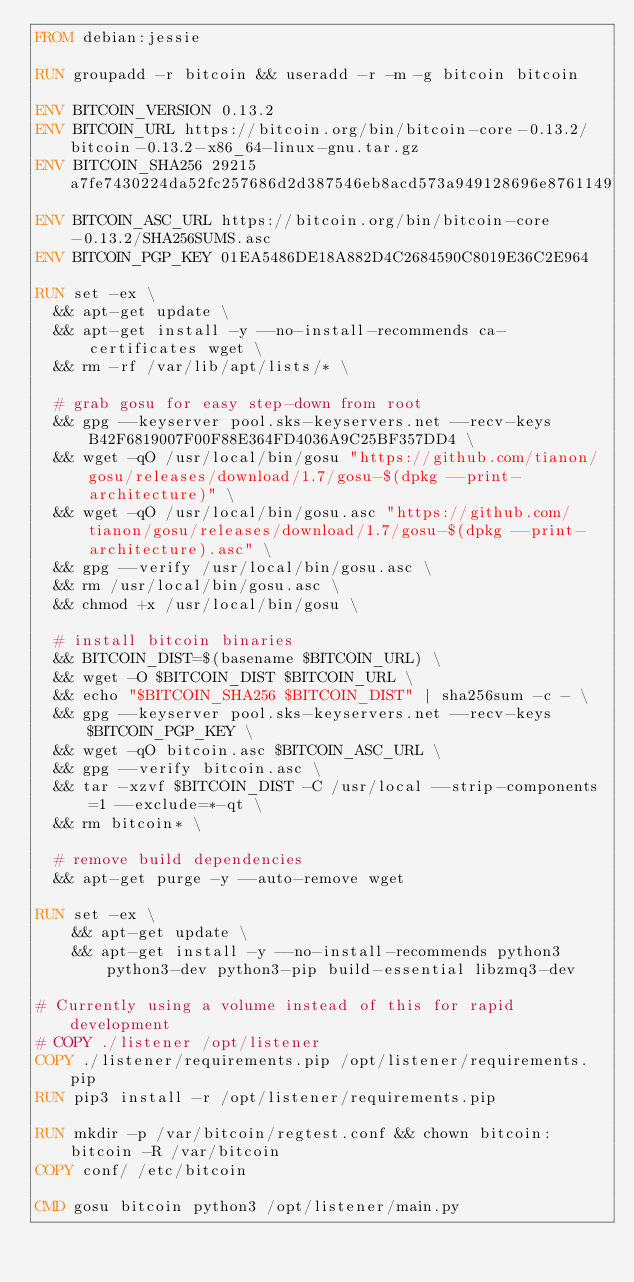<code> <loc_0><loc_0><loc_500><loc_500><_Dockerfile_>FROM debian:jessie

RUN groupadd -r bitcoin && useradd -r -m -g bitcoin bitcoin

ENV BITCOIN_VERSION 0.13.2
ENV BITCOIN_URL https://bitcoin.org/bin/bitcoin-core-0.13.2/bitcoin-0.13.2-x86_64-linux-gnu.tar.gz
ENV BITCOIN_SHA256 29215a7fe7430224da52fc257686d2d387546eb8acd573a949128696e8761149
ENV BITCOIN_ASC_URL https://bitcoin.org/bin/bitcoin-core-0.13.2/SHA256SUMS.asc
ENV BITCOIN_PGP_KEY 01EA5486DE18A882D4C2684590C8019E36C2E964

RUN set -ex \
	&& apt-get update \
	&& apt-get install -y --no-install-recommends ca-certificates wget \
	&& rm -rf /var/lib/apt/lists/* \

	# grab gosu for easy step-down from root
	&& gpg --keyserver pool.sks-keyservers.net --recv-keys B42F6819007F00F88E364FD4036A9C25BF357DD4 \
	&& wget -qO /usr/local/bin/gosu "https://github.com/tianon/gosu/releases/download/1.7/gosu-$(dpkg --print-architecture)" \
	&& wget -qO /usr/local/bin/gosu.asc "https://github.com/tianon/gosu/releases/download/1.7/gosu-$(dpkg --print-architecture).asc" \
	&& gpg --verify /usr/local/bin/gosu.asc \
	&& rm /usr/local/bin/gosu.asc \
	&& chmod +x /usr/local/bin/gosu \

	# install bitcoin binaries
	&& BITCOIN_DIST=$(basename $BITCOIN_URL) \
	&& wget -O $BITCOIN_DIST $BITCOIN_URL \
	&& echo "$BITCOIN_SHA256 $BITCOIN_DIST" | sha256sum -c - \
	&& gpg --keyserver pool.sks-keyservers.net --recv-keys $BITCOIN_PGP_KEY \
	&& wget -qO bitcoin.asc $BITCOIN_ASC_URL \
	&& gpg --verify bitcoin.asc \
	&& tar -xzvf $BITCOIN_DIST -C /usr/local --strip-components=1 --exclude=*-qt \
	&& rm bitcoin* \

	# remove build dependencies
	&& apt-get purge -y --auto-remove wget

RUN set -ex \
    && apt-get update \
    && apt-get install -y --no-install-recommends python3 python3-dev python3-pip build-essential libzmq3-dev

# Currently using a volume instead of this for rapid development
# COPY ./listener /opt/listener
COPY ./listener/requirements.pip /opt/listener/requirements.pip
RUN pip3 install -r /opt/listener/requirements.pip

RUN mkdir -p /var/bitcoin/regtest.conf && chown bitcoin:bitcoin -R /var/bitcoin
COPY conf/ /etc/bitcoin

CMD gosu bitcoin python3 /opt/listener/main.py
</code> 